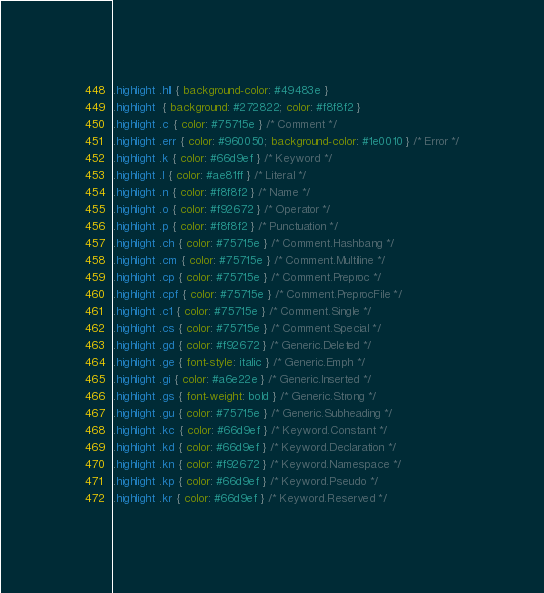Convert code to text. <code><loc_0><loc_0><loc_500><loc_500><_CSS_>.highlight .hll { background-color: #49483e }
.highlight  { background: #272822; color: #f8f8f2 }
.highlight .c { color: #75715e } /* Comment */
.highlight .err { color: #960050; background-color: #1e0010 } /* Error */
.highlight .k { color: #66d9ef } /* Keyword */
.highlight .l { color: #ae81ff } /* Literal */
.highlight .n { color: #f8f8f2 } /* Name */
.highlight .o { color: #f92672 } /* Operator */
.highlight .p { color: #f8f8f2 } /* Punctuation */
.highlight .ch { color: #75715e } /* Comment.Hashbang */
.highlight .cm { color: #75715e } /* Comment.Multiline */
.highlight .cp { color: #75715e } /* Comment.Preproc */
.highlight .cpf { color: #75715e } /* Comment.PreprocFile */
.highlight .c1 { color: #75715e } /* Comment.Single */
.highlight .cs { color: #75715e } /* Comment.Special */
.highlight .gd { color: #f92672 } /* Generic.Deleted */
.highlight .ge { font-style: italic } /* Generic.Emph */
.highlight .gi { color: #a6e22e } /* Generic.Inserted */
.highlight .gs { font-weight: bold } /* Generic.Strong */
.highlight .gu { color: #75715e } /* Generic.Subheading */
.highlight .kc { color: #66d9ef } /* Keyword.Constant */
.highlight .kd { color: #66d9ef } /* Keyword.Declaration */
.highlight .kn { color: #f92672 } /* Keyword.Namespace */
.highlight .kp { color: #66d9ef } /* Keyword.Pseudo */
.highlight .kr { color: #66d9ef } /* Keyword.Reserved */</code> 